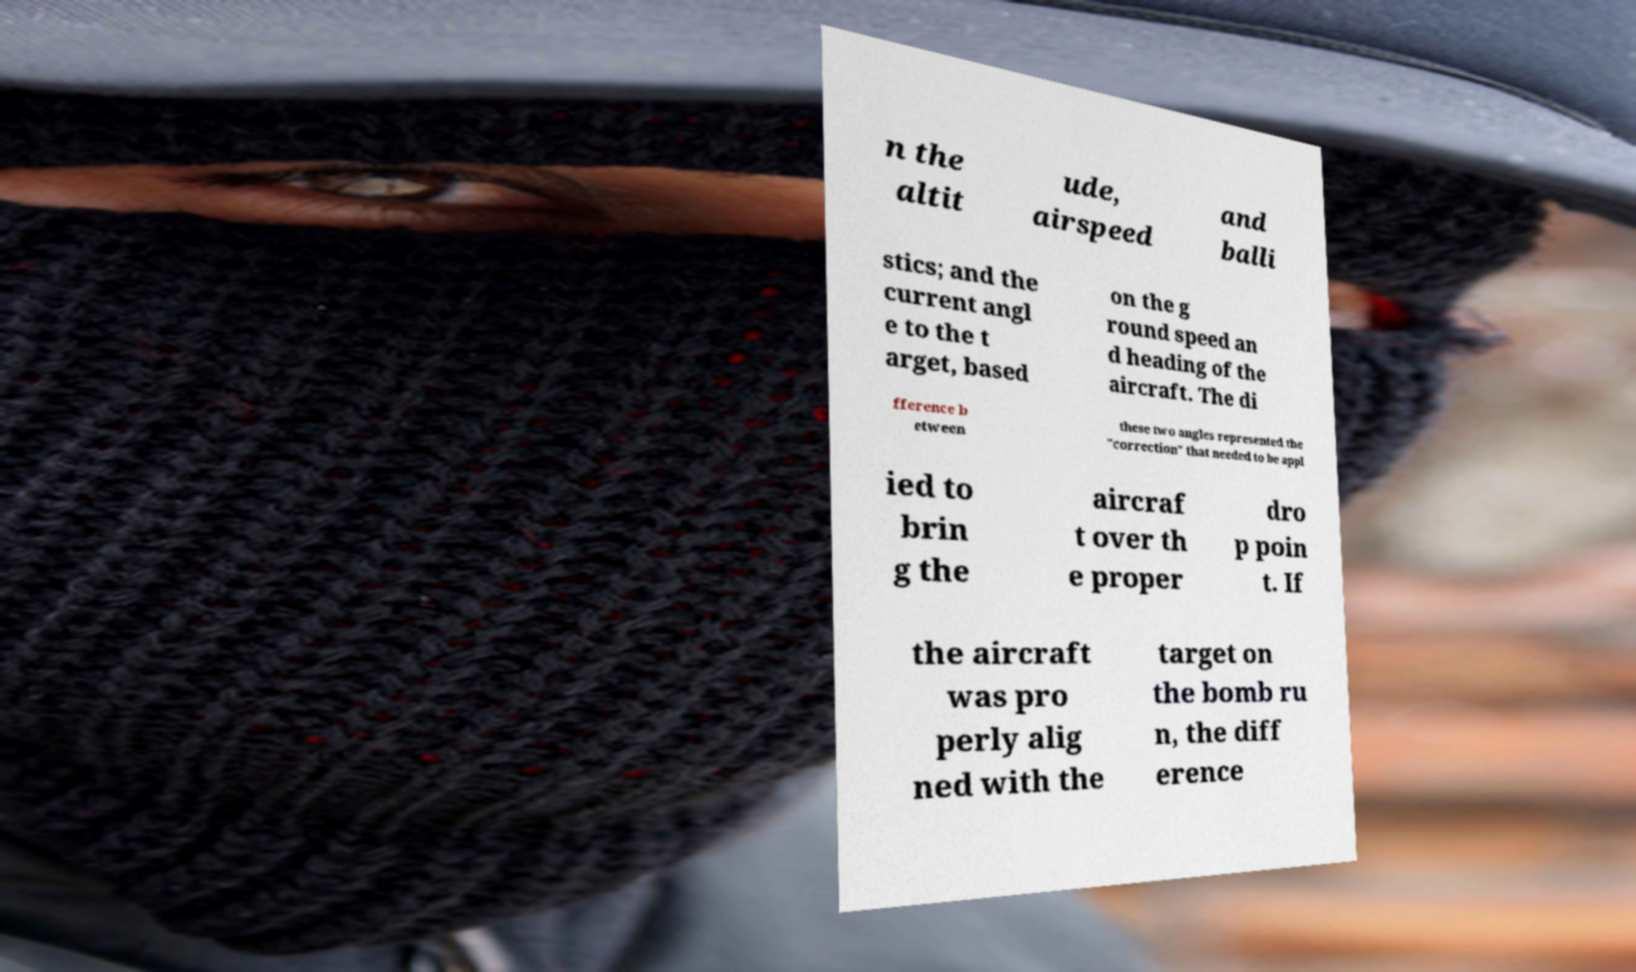Could you extract and type out the text from this image? n the altit ude, airspeed and balli stics; and the current angl e to the t arget, based on the g round speed an d heading of the aircraft. The di fference b etween these two angles represented the "correction" that needed to be appl ied to brin g the aircraf t over th e proper dro p poin t. If the aircraft was pro perly alig ned with the target on the bomb ru n, the diff erence 